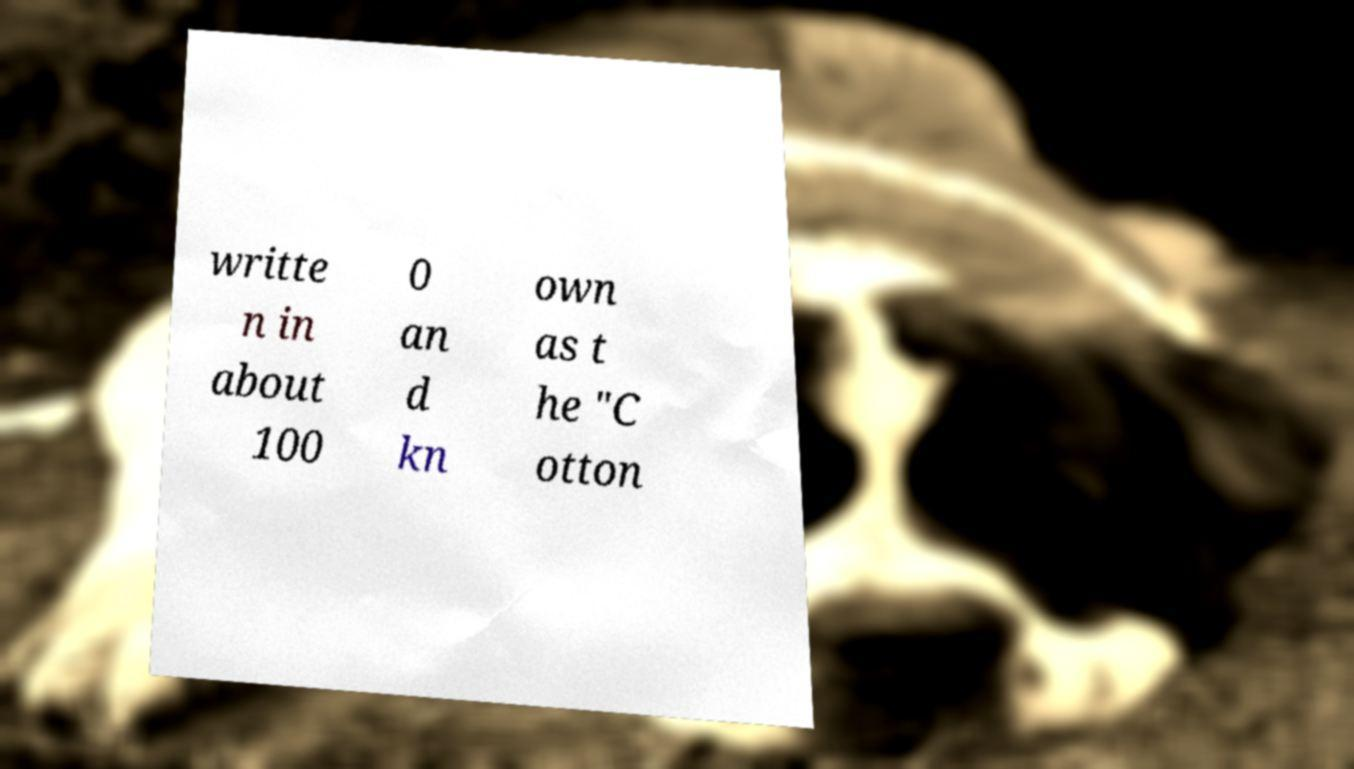Could you extract and type out the text from this image? writte n in about 100 0 an d kn own as t he "C otton 